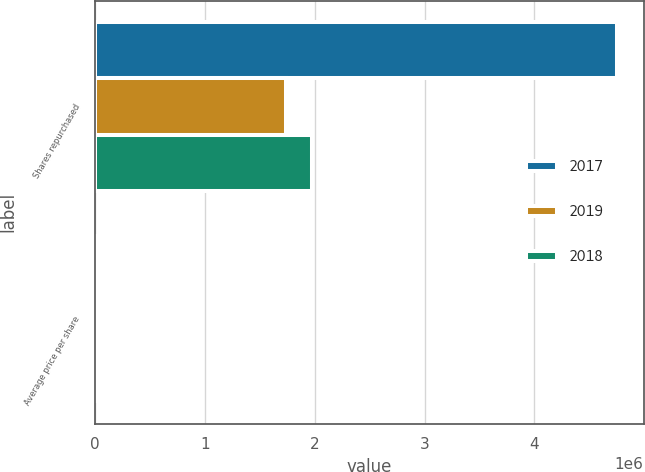Convert chart to OTSL. <chart><loc_0><loc_0><loc_500><loc_500><stacked_bar_chart><ecel><fcel>Shares repurchased<fcel>Average price per share<nl><fcel>2017<fcel>4.75527e+06<fcel>168.23<nl><fcel>2019<fcel>1.73823e+06<fcel>172.59<nl><fcel>2018<fcel>1.97678e+06<fcel>133.9<nl></chart> 